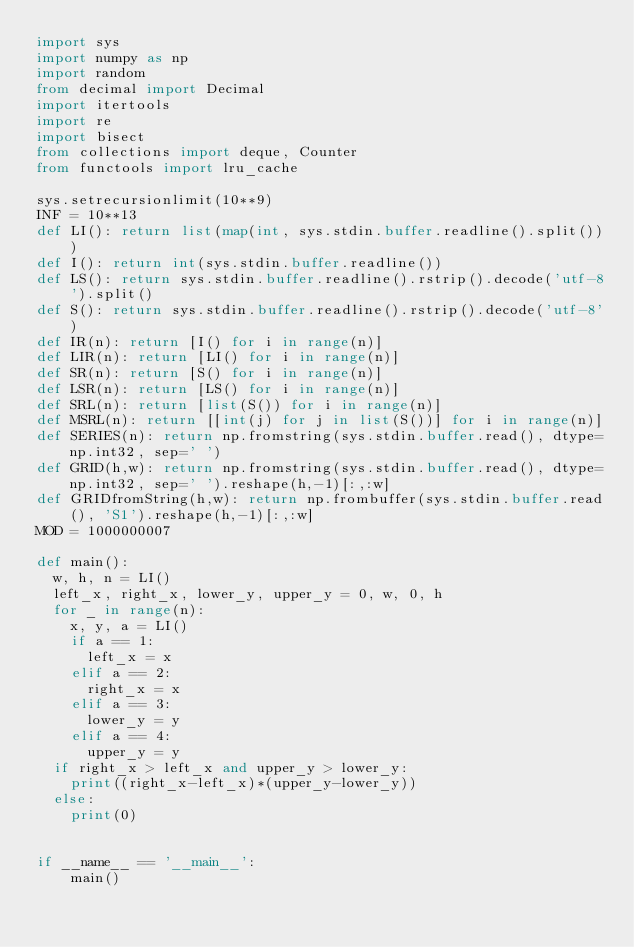Convert code to text. <code><loc_0><loc_0><loc_500><loc_500><_Python_>import sys
import numpy as np
import random
from decimal import Decimal
import itertools
import re
import bisect
from collections import deque, Counter
from functools import lru_cache

sys.setrecursionlimit(10**9)
INF = 10**13
def LI(): return list(map(int, sys.stdin.buffer.readline().split()))
def I(): return int(sys.stdin.buffer.readline())
def LS(): return sys.stdin.buffer.readline().rstrip().decode('utf-8').split()
def S(): return sys.stdin.buffer.readline().rstrip().decode('utf-8')
def IR(n): return [I() for i in range(n)]
def LIR(n): return [LI() for i in range(n)]
def SR(n): return [S() for i in range(n)]
def LSR(n): return [LS() for i in range(n)]
def SRL(n): return [list(S()) for i in range(n)]
def MSRL(n): return [[int(j) for j in list(S())] for i in range(n)]
def SERIES(n): return np.fromstring(sys.stdin.buffer.read(), dtype=np.int32, sep=' ')
def GRID(h,w): return np.fromstring(sys.stdin.buffer.read(), dtype=np.int32, sep=' ').reshape(h,-1)[:,:w]
def GRIDfromString(h,w): return np.frombuffer(sys.stdin.buffer.read(), 'S1').reshape(h,-1)[:,:w]
MOD = 1000000007

def main():
	w, h, n = LI()
	left_x, right_x, lower_y, upper_y = 0, w, 0, h
	for _ in range(n):
		x, y, a = LI()
		if a == 1:
			left_x = x
		elif a == 2:
			right_x = x
		elif a == 3:
			lower_y = y
		elif a == 4:
			upper_y = y
	if right_x > left_x and upper_y > lower_y:
		print((right_x-left_x)*(upper_y-lower_y))
	else:
		print(0)


if __name__ == '__main__':
    main()</code> 